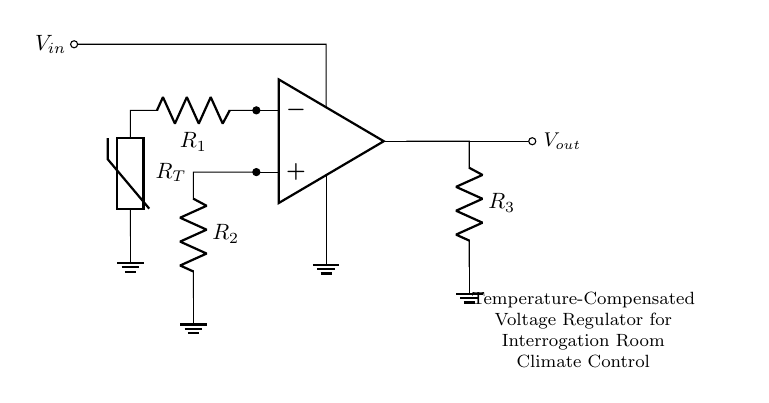What type of amplifier is used in this circuit? The circuit uses an operational amplifier, which is indicated by the op amp symbol in the diagram.
Answer: Operational amplifier What are the resistors labeled in the circuit? The circuit contains three resistors labeled as R1, R2, and R3, which are clearly shown next to their respective symbols.
Answer: R1, R2, R3 How does the thermistor function in the circuit? The thermistor acts as a sensor that changes resistance with temperature, affecting the voltage output in relation to temperature changes, which is essential for temperature compensation.
Answer: Sensor What is the role of the voltage input in this circuit? Voltage input (Vin) provides the initial electrical power necessary for the operational amplifier and the rest of the circuit to function effectively.
Answer: Initial power What output voltage condition can trigger changes in the regulator? Changes in the ambient temperature can alter the resistance of the thermistor, thus modifying the output voltage to maintain the desired climate control, reflecting the adaptiveness of the circuit.
Answer: Ambient temperature How does this circuit compensate for temperature variations? The circuit utilizes a thermistor in conjunction with the operational amplifier to dynamically adjust its output voltage based on temperature changes, ensuring stable climate control in the interrogation room.
Answer: Dynamic adjustment 